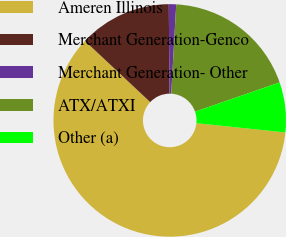<chart> <loc_0><loc_0><loc_500><loc_500><pie_chart><fcel>Ameren Illinois<fcel>Merchant Generation-Genco<fcel>Merchant Generation- Other<fcel>ATX/ATXI<fcel>Other (a)<nl><fcel>60.34%<fcel>12.88%<fcel>1.02%<fcel>18.81%<fcel>6.95%<nl></chart> 